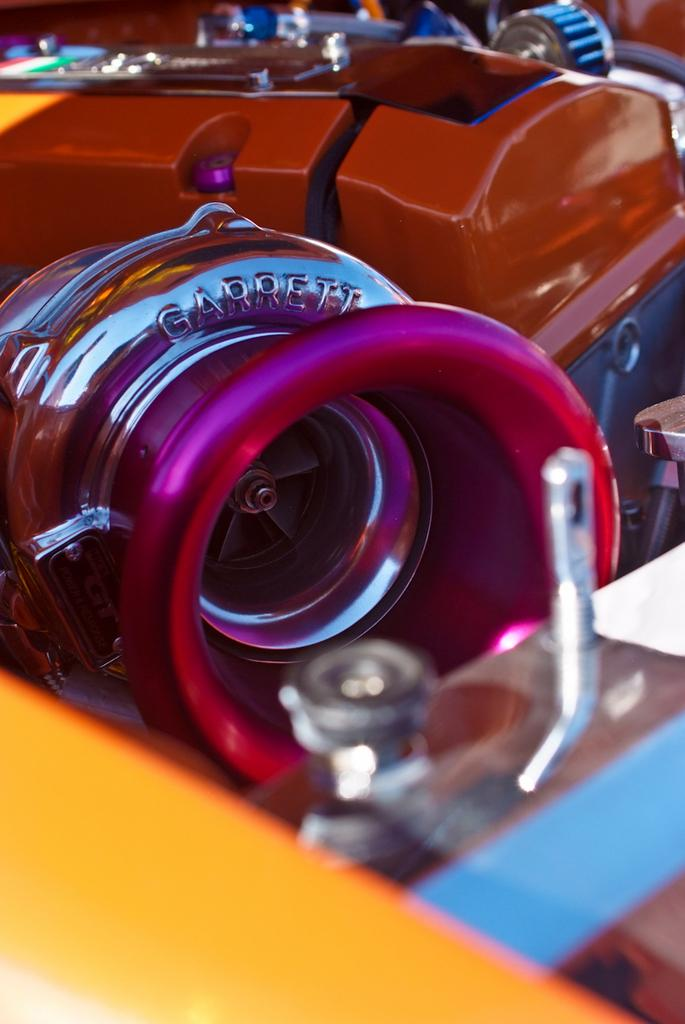What type of objects can be seen in the image? There are metal objects in the image. Can you describe the background of the image? The background of the image is blurry. How many passengers are visible on the bushes in the image? There are no passengers or bushes present in the image; it only features metal objects with a blurry background. 